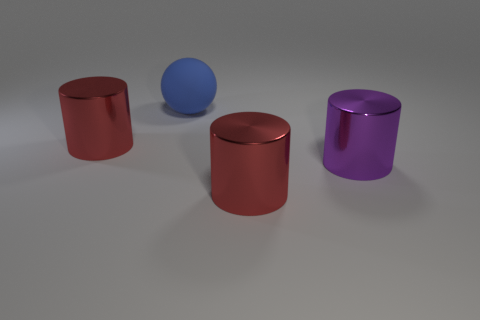There is a red metal thing that is to the left of the red shiny thing that is in front of the large object to the left of the sphere; what is its size?
Give a very brief answer. Large. There is a big sphere; are there any metallic cylinders on the left side of it?
Make the answer very short. Yes. How many objects are either red metallic cylinders on the left side of the large blue rubber sphere or tiny green metallic cubes?
Your answer should be compact. 1. Do the sphere and the red cylinder that is behind the large purple cylinder have the same size?
Your answer should be compact. Yes. The large object that is behind the purple metal cylinder and in front of the blue ball is what color?
Your answer should be compact. Red. How many things are objects left of the big ball or red shiny things on the left side of the large purple thing?
Offer a very short reply. 2. What color is the large cylinder on the left side of the thing that is behind the big shiny thing that is on the left side of the blue rubber object?
Offer a terse response. Red. Are there any gray things that have the same shape as the big purple shiny object?
Ensure brevity in your answer.  No. How many big objects are there?
Offer a terse response. 4. What is the shape of the purple thing?
Your response must be concise. Cylinder. 